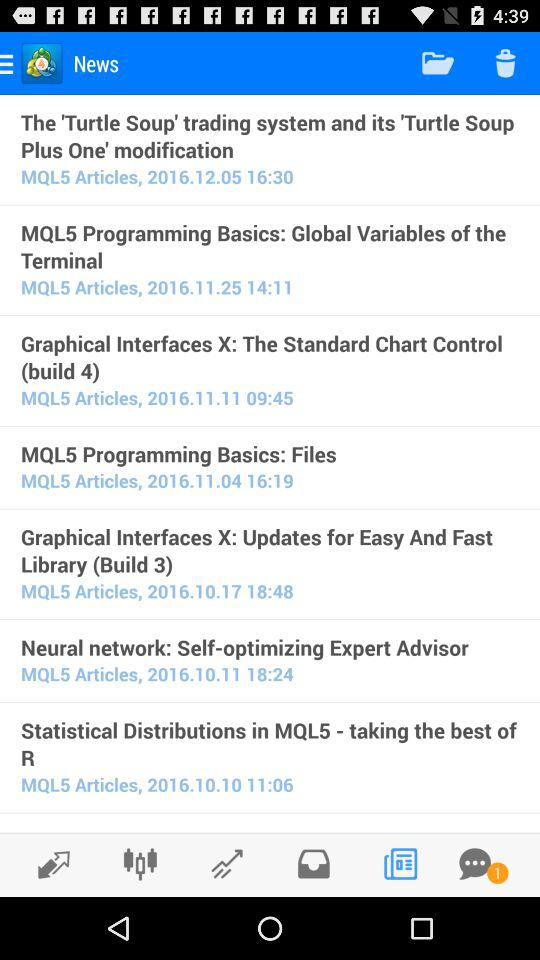What is the posted time of "MQL5 Programming Basics: Global Variables of the Terminal"? The posted time of "MQL5 Programming Basics: Global Variables of the Terminal" is 14:11. 